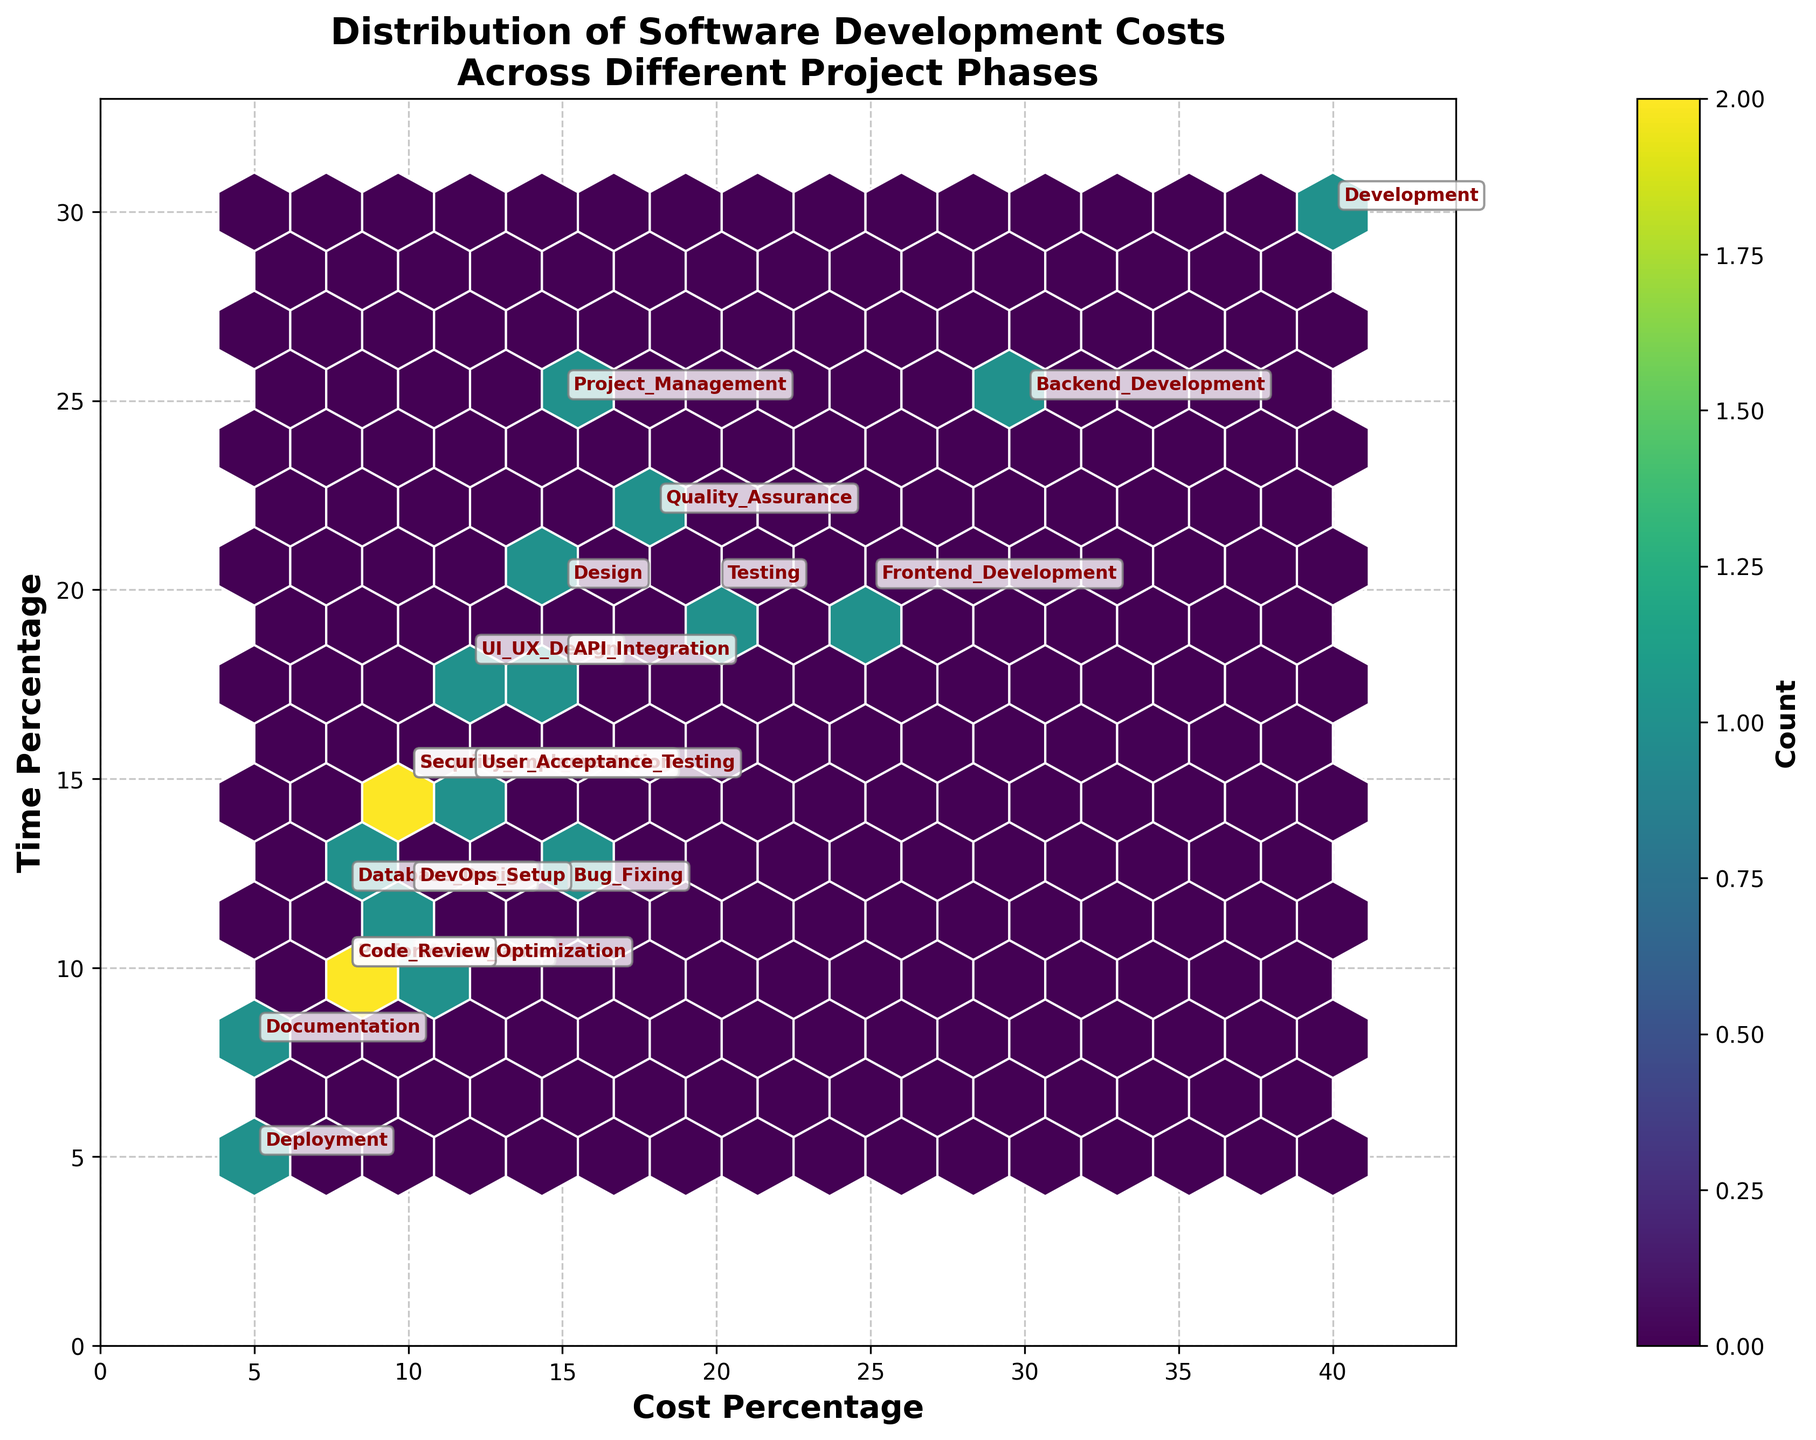What is the title of the plot? The plot's title is often located at the top and in a larger font size. In this figure, the title is "Distribution of Software Development Costs Across Different Project Phases".
Answer: Distribution of Software Development Costs Across Different Project Phases What are the labels for the x-axis and y-axis? The x-axis and y-axis labels provide context for the data. In the figure, the x-axis is labeled "Cost Percentage" and the y-axis is labeled "Time Percentage".
Answer: Cost Percentage; Time Percentage What colors are used for the hexagonal bins? The hexagonal bins are colored using a gradient. In this plot, a 'viridis' color map is used, which transitions from purple to yellow. The edge colors of the bins are white.
Answer: Transition from purple to yellow, with white edges Which phase has a Cost Percentage of 40% and a Time Percentage of 30%? To determine this, locate the annotation placed on the hexbin at coordinates (40, 30). The figure shows "Development" at these coordinates.
Answer: Development How many phases have a Cost Percentage greater than 20%? Identify and count the textual annotations where Cost Percentage is greater than 20. In this case, the phases are "Development", "Backend Development", "Frontend Development", and "Quality Assurance".
Answer: 4 Which phase has the lowest Time Percentage? Find the phase with the smallest value on the y-axis. The phase "Deployment" has a Time Percentage of 5%.
Answer: Deployment What is the range of Cost Percentages displayed on the x-axis? The x-axis limits are typically set by the maximum value in the dataset, with some padding. Here, the x-axis goes from 0 to (max 40 * 1.1 ≈ 44).
Answer: 0 to 44 Which phase has both Cost Percentage and Time Percentage equal to 10%? Locate the annotation at coordinates (10, 10). The phase "Maintenance" is found at this coordinate.
Answer: Maintenance Are there any phases with a Time Percentage of 25%? Scan for any annotations at y = 25. The phases "Project Management" and "Backend Development" have Time Percentages of 25%.
Answer: Project Management; Backend Development 